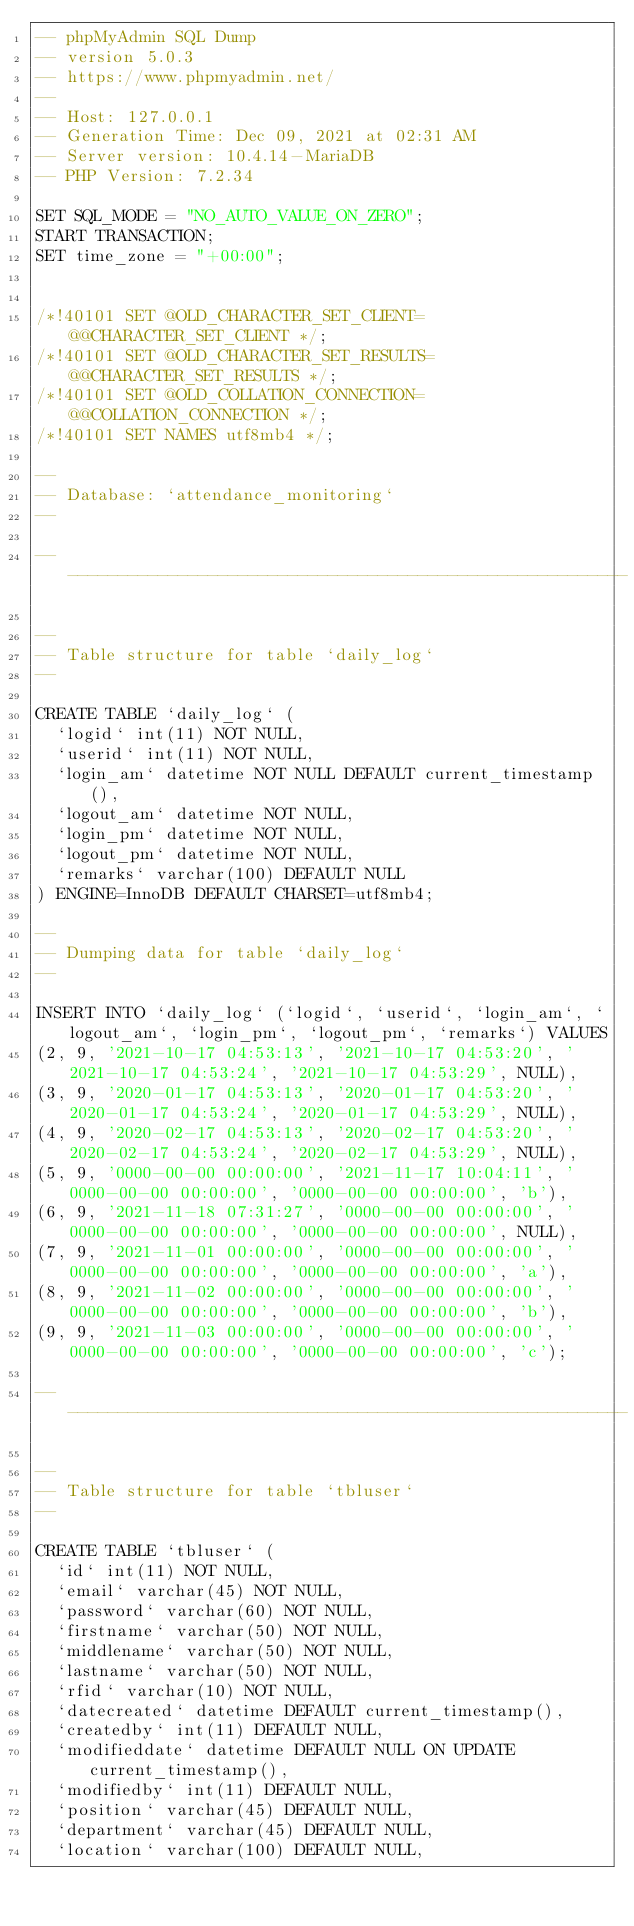Convert code to text. <code><loc_0><loc_0><loc_500><loc_500><_SQL_>-- phpMyAdmin SQL Dump
-- version 5.0.3
-- https://www.phpmyadmin.net/
--
-- Host: 127.0.0.1
-- Generation Time: Dec 09, 2021 at 02:31 AM
-- Server version: 10.4.14-MariaDB
-- PHP Version: 7.2.34

SET SQL_MODE = "NO_AUTO_VALUE_ON_ZERO";
START TRANSACTION;
SET time_zone = "+00:00";


/*!40101 SET @OLD_CHARACTER_SET_CLIENT=@@CHARACTER_SET_CLIENT */;
/*!40101 SET @OLD_CHARACTER_SET_RESULTS=@@CHARACTER_SET_RESULTS */;
/*!40101 SET @OLD_COLLATION_CONNECTION=@@COLLATION_CONNECTION */;
/*!40101 SET NAMES utf8mb4 */;

--
-- Database: `attendance_monitoring`
--

-- --------------------------------------------------------

--
-- Table structure for table `daily_log`
--

CREATE TABLE `daily_log` (
  `logid` int(11) NOT NULL,
  `userid` int(11) NOT NULL,
  `login_am` datetime NOT NULL DEFAULT current_timestamp(),
  `logout_am` datetime NOT NULL,
  `login_pm` datetime NOT NULL,
  `logout_pm` datetime NOT NULL,
  `remarks` varchar(100) DEFAULT NULL
) ENGINE=InnoDB DEFAULT CHARSET=utf8mb4;

--
-- Dumping data for table `daily_log`
--

INSERT INTO `daily_log` (`logid`, `userid`, `login_am`, `logout_am`, `login_pm`, `logout_pm`, `remarks`) VALUES
(2, 9, '2021-10-17 04:53:13', '2021-10-17 04:53:20', '2021-10-17 04:53:24', '2021-10-17 04:53:29', NULL),
(3, 9, '2020-01-17 04:53:13', '2020-01-17 04:53:20', '2020-01-17 04:53:24', '2020-01-17 04:53:29', NULL),
(4, 9, '2020-02-17 04:53:13', '2020-02-17 04:53:20', '2020-02-17 04:53:24', '2020-02-17 04:53:29', NULL),
(5, 9, '0000-00-00 00:00:00', '2021-11-17 10:04:11', '0000-00-00 00:00:00', '0000-00-00 00:00:00', 'b'),
(6, 9, '2021-11-18 07:31:27', '0000-00-00 00:00:00', '0000-00-00 00:00:00', '0000-00-00 00:00:00', NULL),
(7, 9, '2021-11-01 00:00:00', '0000-00-00 00:00:00', '0000-00-00 00:00:00', '0000-00-00 00:00:00', 'a'),
(8, 9, '2021-11-02 00:00:00', '0000-00-00 00:00:00', '0000-00-00 00:00:00', '0000-00-00 00:00:00', 'b'),
(9, 9, '2021-11-03 00:00:00', '0000-00-00 00:00:00', '0000-00-00 00:00:00', '0000-00-00 00:00:00', 'c');

-- --------------------------------------------------------

--
-- Table structure for table `tbluser`
--

CREATE TABLE `tbluser` (
  `id` int(11) NOT NULL,
  `email` varchar(45) NOT NULL,
  `password` varchar(60) NOT NULL,
  `firstname` varchar(50) NOT NULL,
  `middlename` varchar(50) NOT NULL,
  `lastname` varchar(50) NOT NULL,
  `rfid` varchar(10) NOT NULL,
  `datecreated` datetime DEFAULT current_timestamp(),
  `createdby` int(11) DEFAULT NULL,
  `modifieddate` datetime DEFAULT NULL ON UPDATE current_timestamp(),
  `modifiedby` int(11) DEFAULT NULL,
  `position` varchar(45) DEFAULT NULL,
  `department` varchar(45) DEFAULT NULL,
  `location` varchar(100) DEFAULT NULL,</code> 